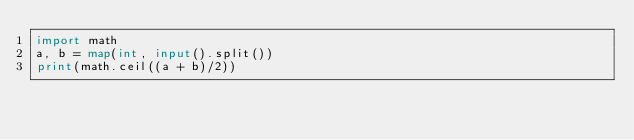<code> <loc_0><loc_0><loc_500><loc_500><_Python_>import math
a, b = map(int, input().split())
print(math.ceil((a + b)/2))</code> 